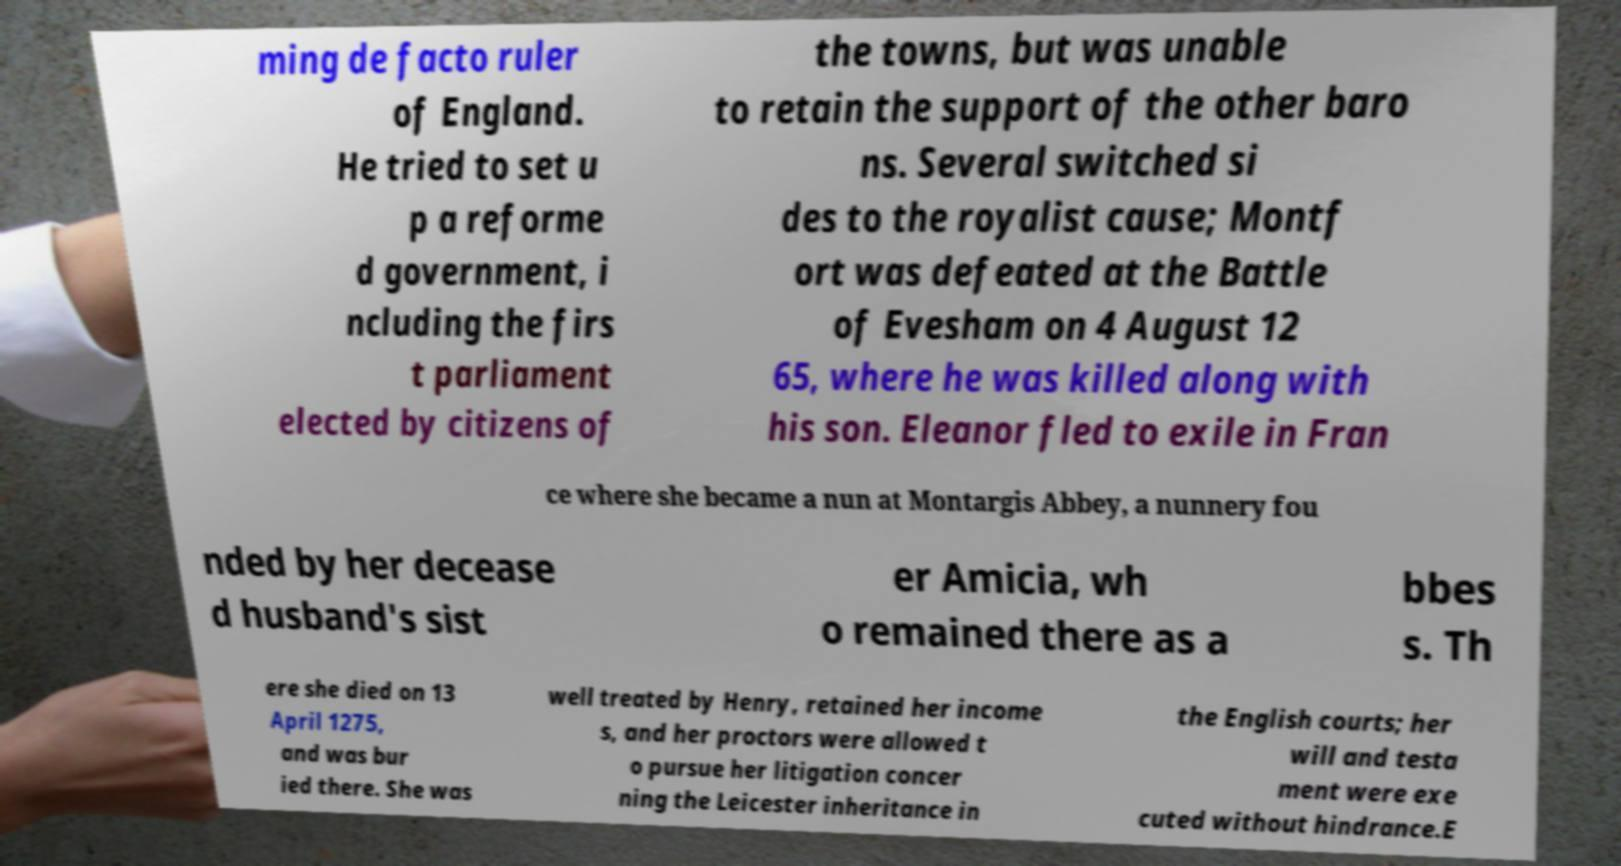Please identify and transcribe the text found in this image. ming de facto ruler of England. He tried to set u p a reforme d government, i ncluding the firs t parliament elected by citizens of the towns, but was unable to retain the support of the other baro ns. Several switched si des to the royalist cause; Montf ort was defeated at the Battle of Evesham on 4 August 12 65, where he was killed along with his son. Eleanor fled to exile in Fran ce where she became a nun at Montargis Abbey, a nunnery fou nded by her decease d husband's sist er Amicia, wh o remained there as a bbes s. Th ere she died on 13 April 1275, and was bur ied there. She was well treated by Henry, retained her income s, and her proctors were allowed t o pursue her litigation concer ning the Leicester inheritance in the English courts; her will and testa ment were exe cuted without hindrance.E 